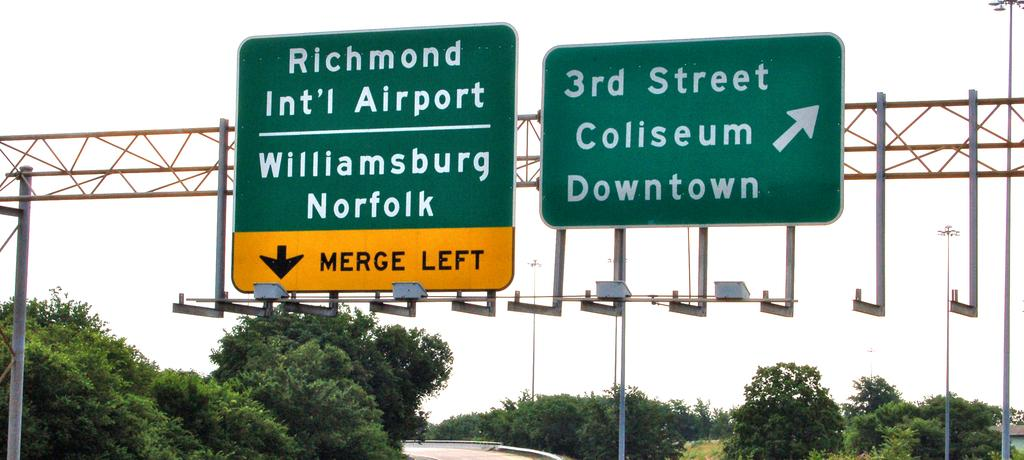<image>
Present a compact description of the photo's key features. a few signs telling where street signs and exits are 